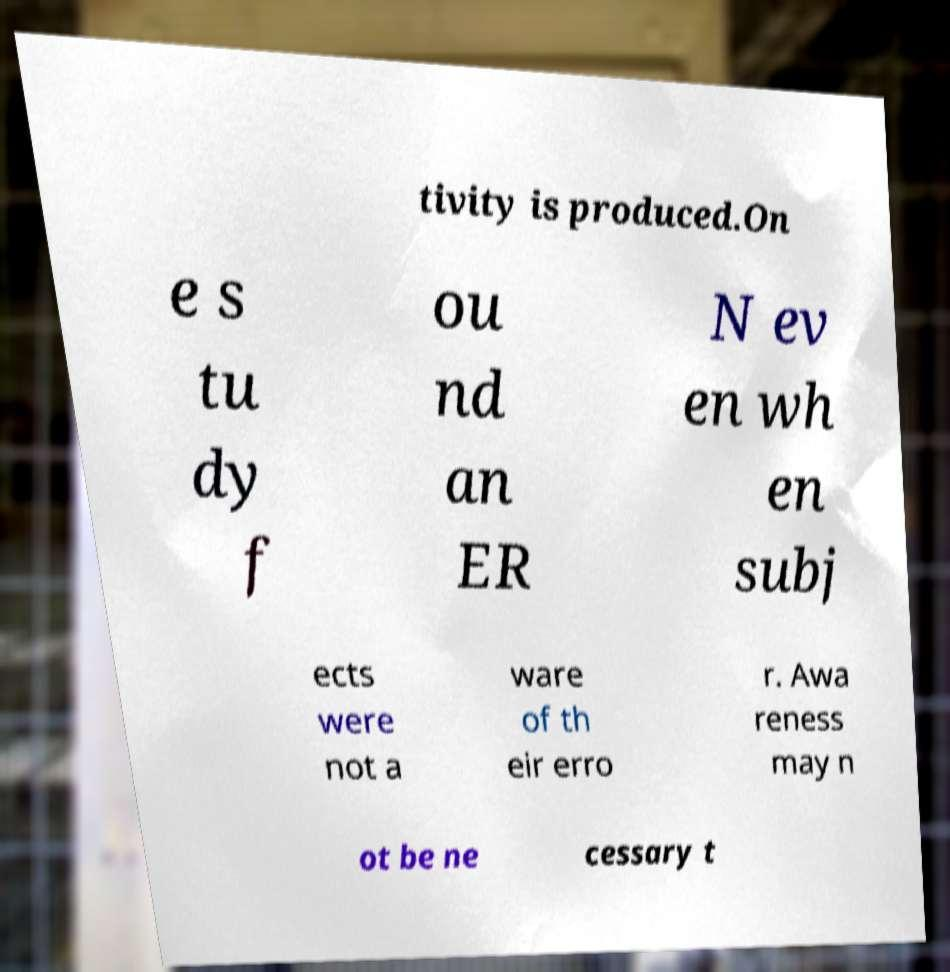Please read and relay the text visible in this image. What does it say? tivity is produced.On e s tu dy f ou nd an ER N ev en wh en subj ects were not a ware of th eir erro r. Awa reness may n ot be ne cessary t 